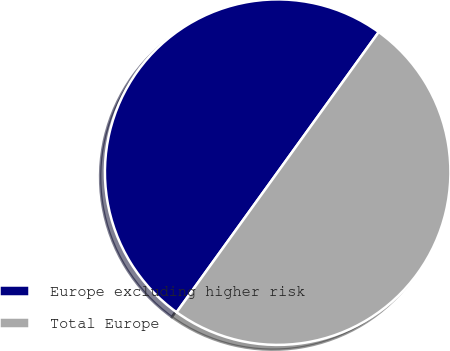<chart> <loc_0><loc_0><loc_500><loc_500><pie_chart><fcel>Europe excluding higher risk<fcel>Total Europe<nl><fcel>50.0%<fcel>50.0%<nl></chart> 